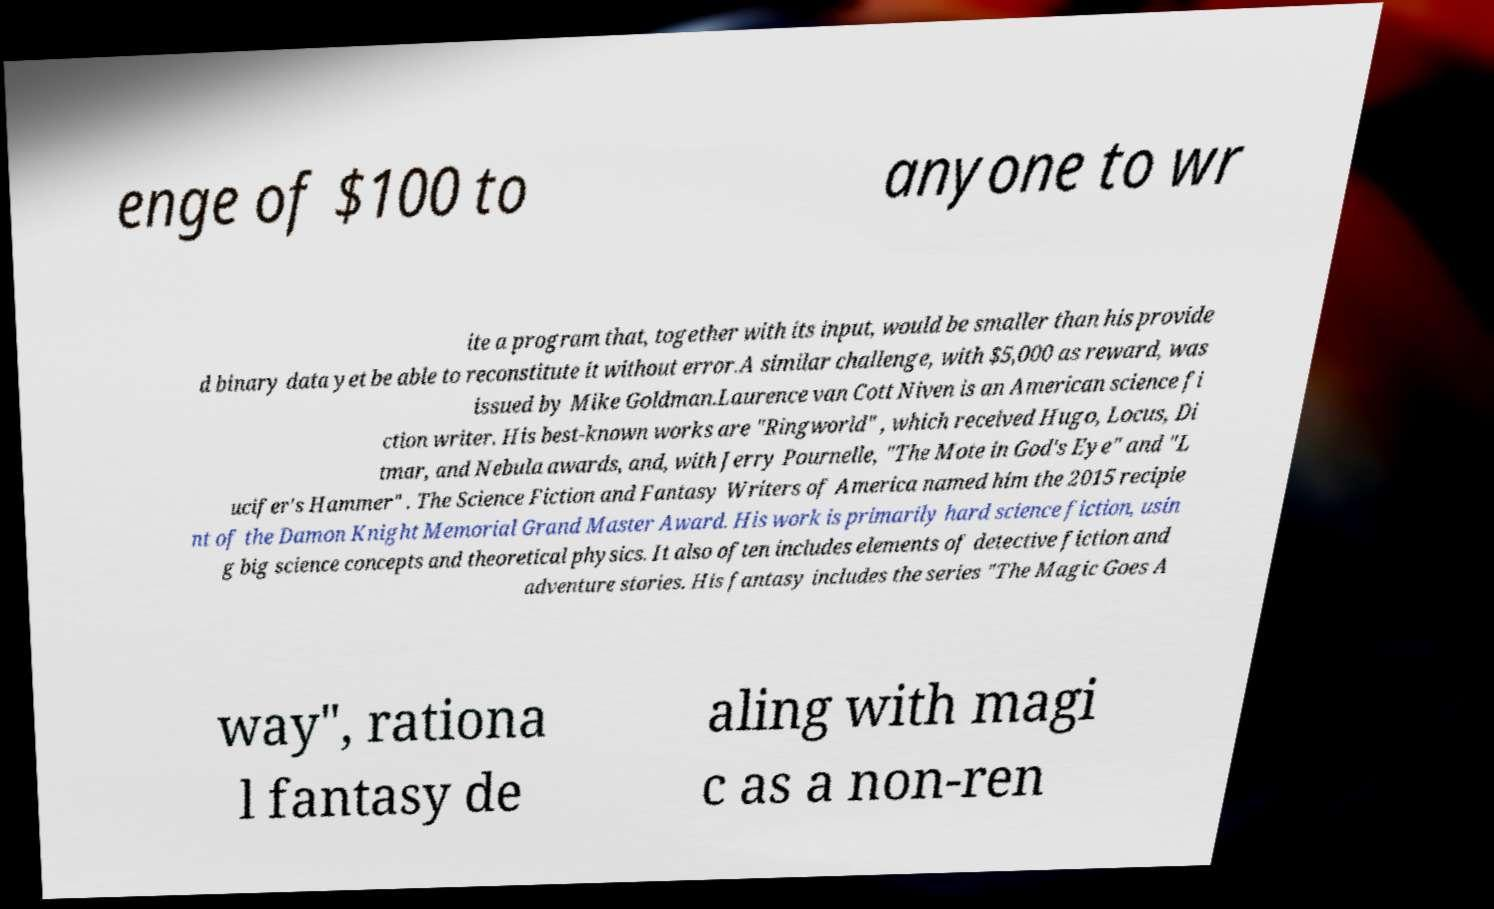Can you read and provide the text displayed in the image?This photo seems to have some interesting text. Can you extract and type it out for me? enge of $100 to anyone to wr ite a program that, together with its input, would be smaller than his provide d binary data yet be able to reconstitute it without error.A similar challenge, with $5,000 as reward, was issued by Mike Goldman.Laurence van Cott Niven is an American science fi ction writer. His best-known works are "Ringworld" , which received Hugo, Locus, Di tmar, and Nebula awards, and, with Jerry Pournelle, "The Mote in God's Eye" and "L ucifer's Hammer" . The Science Fiction and Fantasy Writers of America named him the 2015 recipie nt of the Damon Knight Memorial Grand Master Award. His work is primarily hard science fiction, usin g big science concepts and theoretical physics. It also often includes elements of detective fiction and adventure stories. His fantasy includes the series "The Magic Goes A way", rationa l fantasy de aling with magi c as a non-ren 